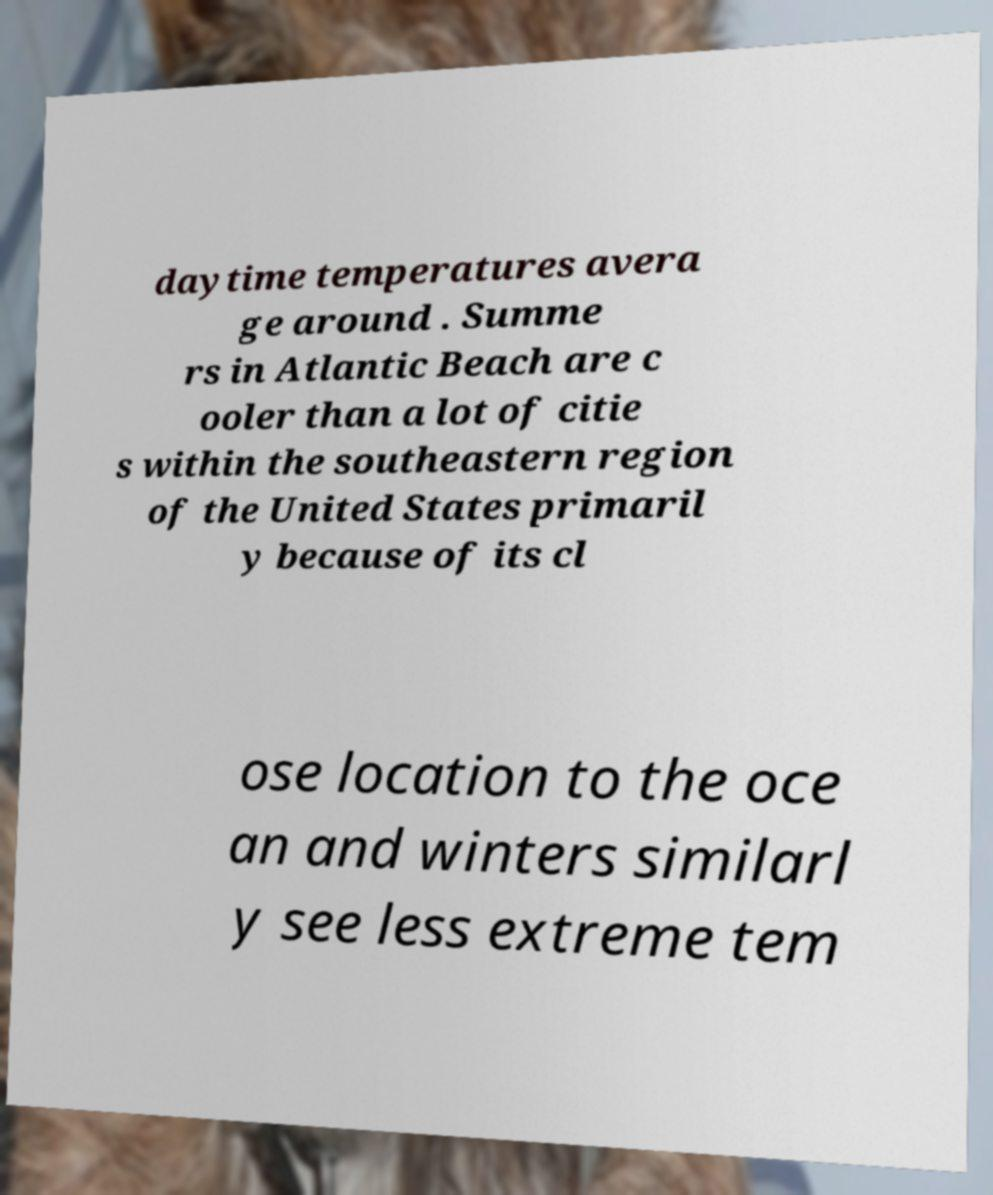Please identify and transcribe the text found in this image. daytime temperatures avera ge around . Summe rs in Atlantic Beach are c ooler than a lot of citie s within the southeastern region of the United States primaril y because of its cl ose location to the oce an and winters similarl y see less extreme tem 